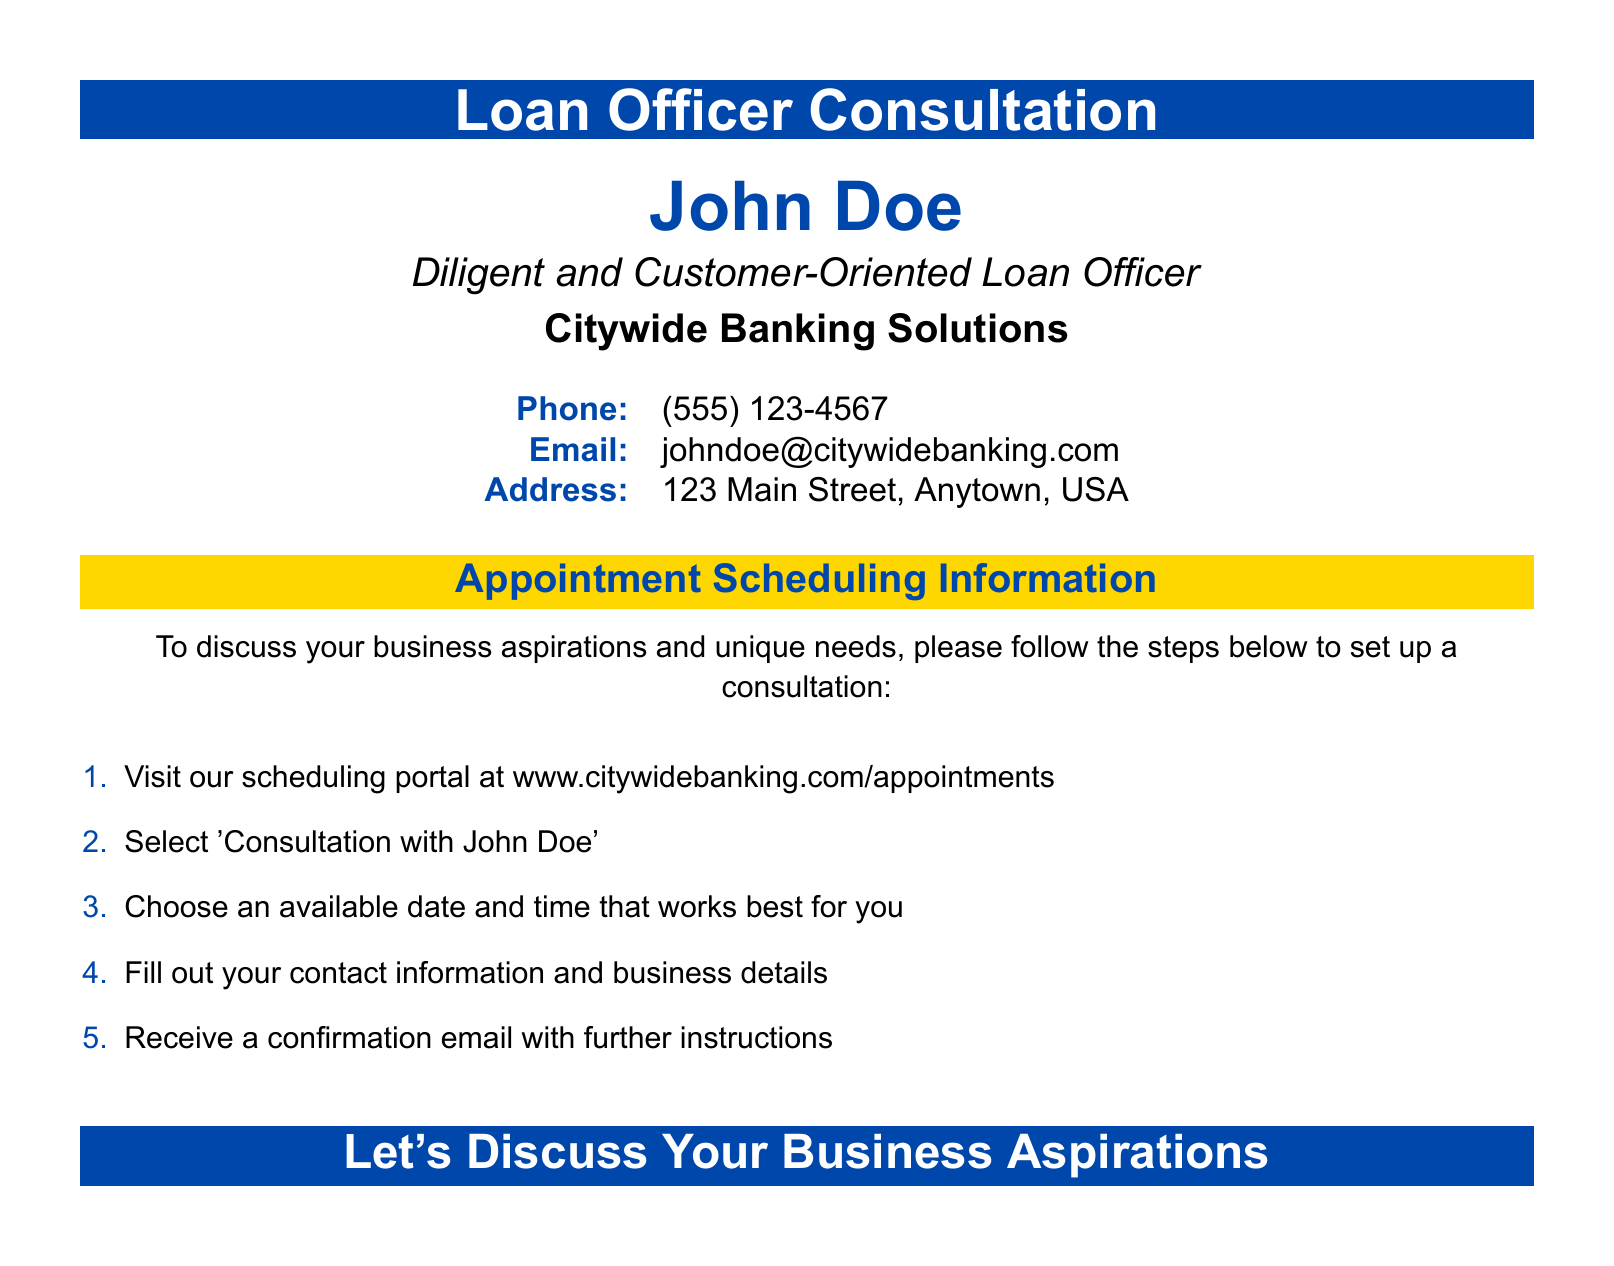What is the name of the loan officer? The name of the loan officer is clearly stated in the document, which is John Doe.
Answer: John Doe What is the phone number for scheduling? The document provides a phone number for the loan officer, which is (555) 123-4567.
Answer: (555) 123-4567 What is the email address provided? The email address listed for contact is johndoe@citywidebanking.com.
Answer: johndoe@citywidebanking.com Where is the office located? The address of the loan officer's office is found in the document, which is 123 Main Street, Anytown, USA.
Answer: 123 Main Street, Anytown, USA What platform should be visited for scheduling? The document specifies the scheduling portal as www.citywidebanking.com/appointments.
Answer: www.citywidebanking.com/appointments How many steps are listed for scheduling an appointment? There are five steps mentioned in the document for setting up a consultation.
Answer: 5 What is the primary purpose of the consultation? The primary purpose of the consultation is to discuss your business aspirations and unique needs.
Answer: Discuss your business aspirations What is the color of the appointment scheduling section? The appointment scheduling section is highlighted with a second color which is gold.
Answer: Gold What does the document encourage you to do at the end? The document includes a call to action encouraging you to discuss your business aspirations.
Answer: Discuss your business aspirations 